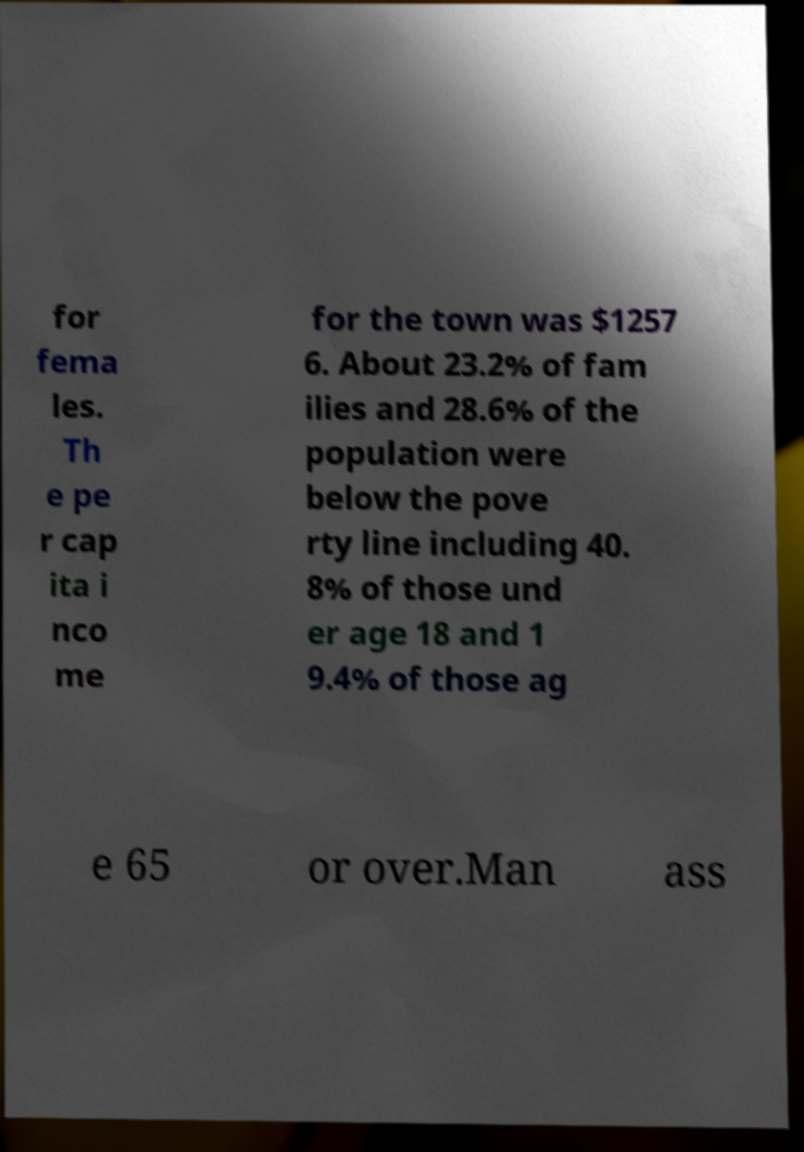Can you accurately transcribe the text from the provided image for me? for fema les. Th e pe r cap ita i nco me for the town was $1257 6. About 23.2% of fam ilies and 28.6% of the population were below the pove rty line including 40. 8% of those und er age 18 and 1 9.4% of those ag e 65 or over.Man ass 